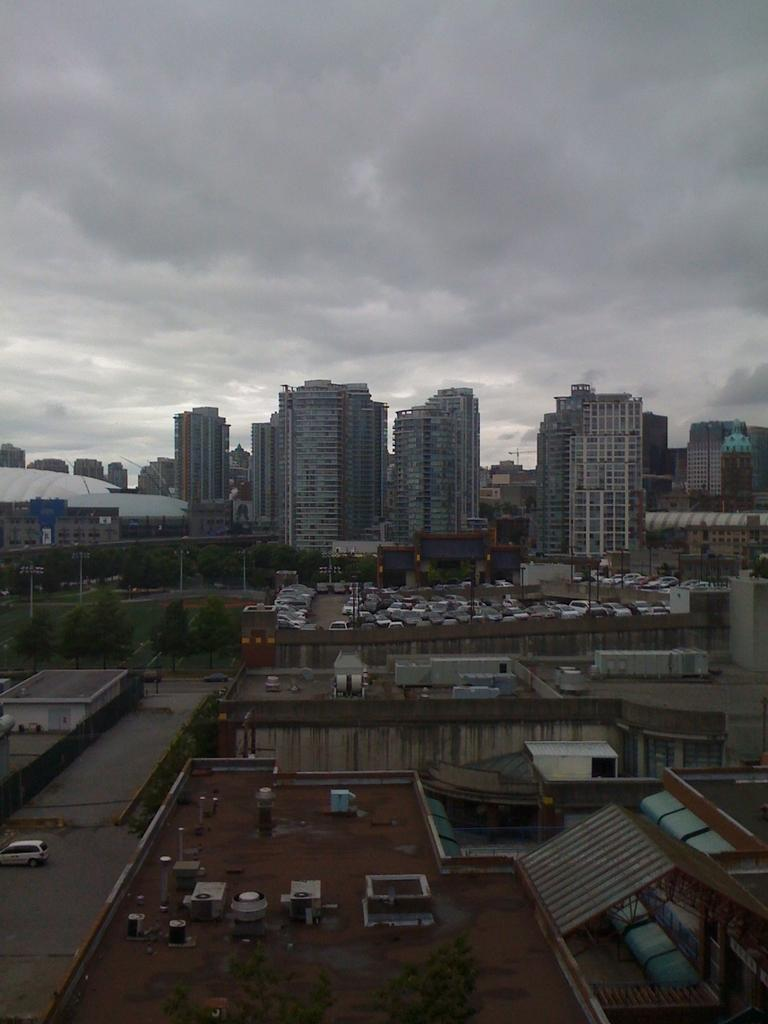What type of structures can be seen in the image? There are buildings in the image. What else is present in the image besides buildings? There are vehicles and trees visible in the image. What can be seen in the background of the image? There are clouds visible in the background of the image. How many frogs are sitting on the buildings in the image? There are no frogs present in the image; it features buildings, vehicles, trees, and clouds. Is the image taken during the night? The image does not indicate whether it was taken during the day or night, but the presence of clouds suggests it might be daytime. 